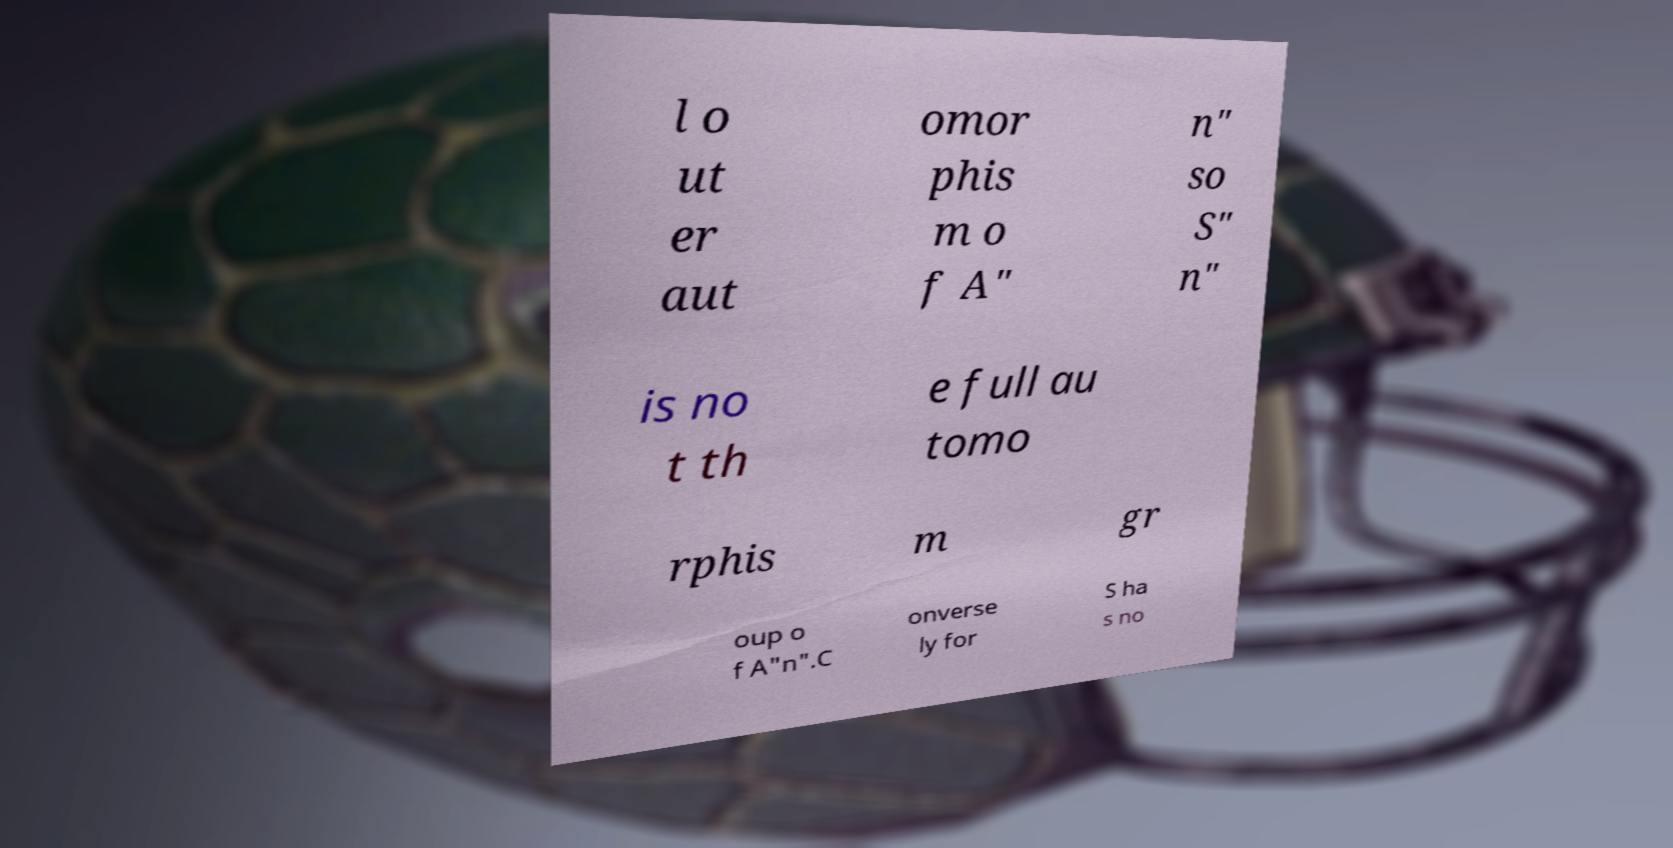Can you accurately transcribe the text from the provided image for me? l o ut er aut omor phis m o f A" n" so S" n" is no t th e full au tomo rphis m gr oup o f A"n".C onverse ly for S ha s no 